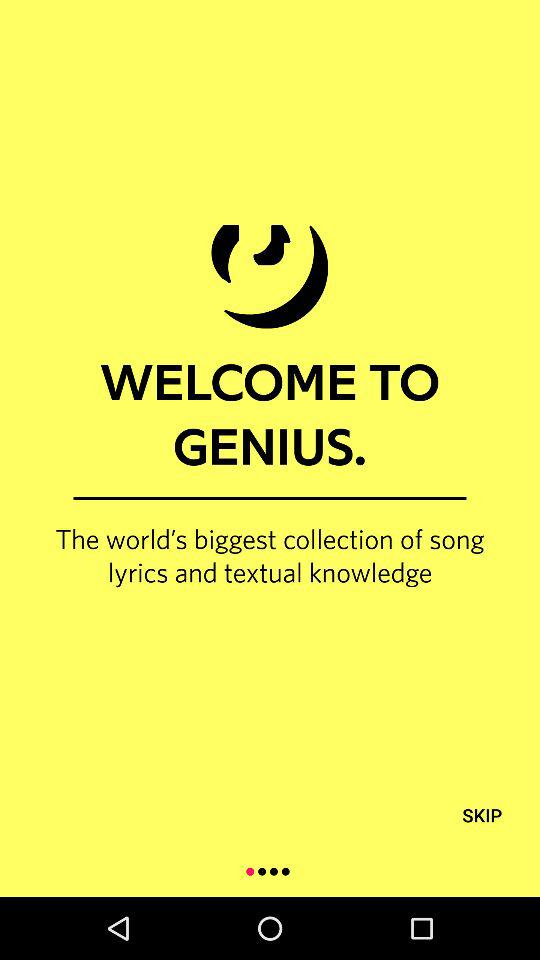Who is this application powered by?
When the provided information is insufficient, respond with <no answer>. <no answer> 